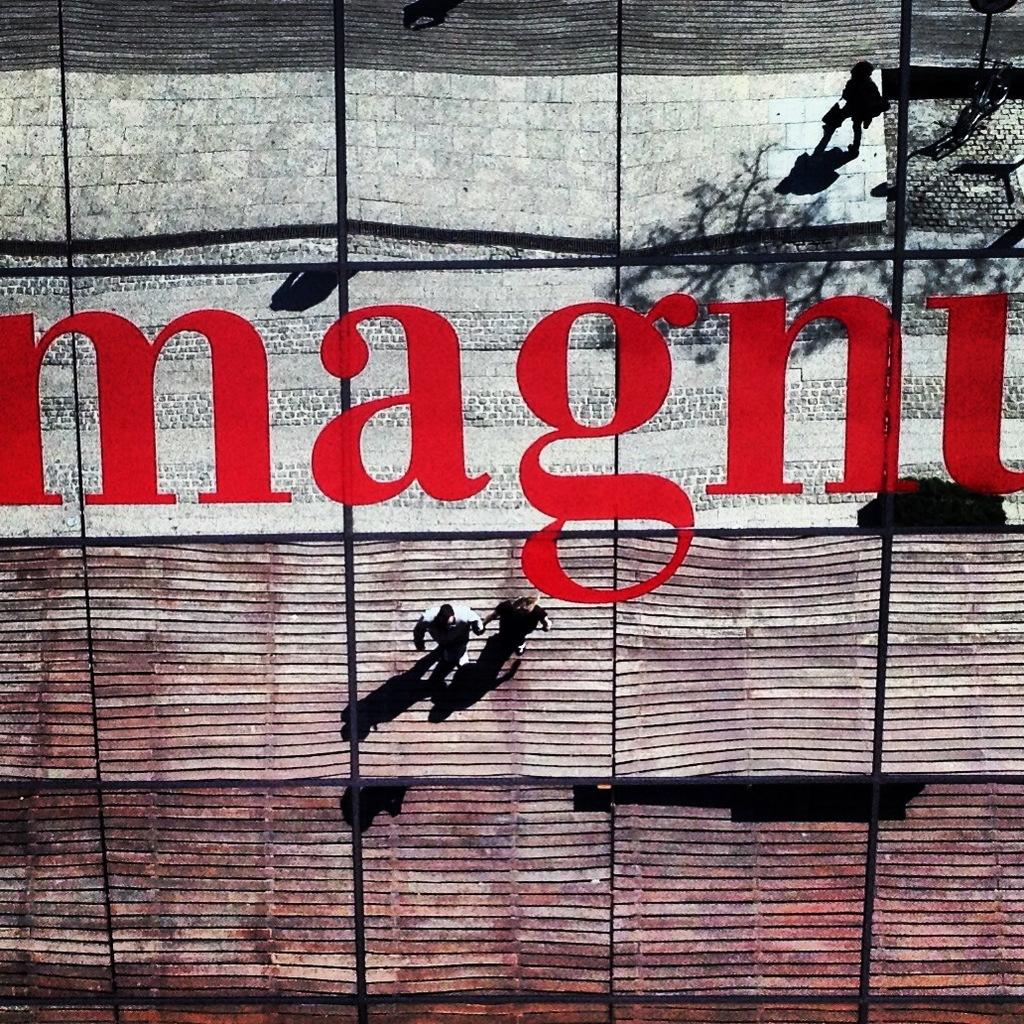Who or what is present in the image? There are people in the image. What are the people doing in the image? The people are walking. What type of celery can be seen in the image? There is no celery present in the image. How many oranges are being carried by the people in the image? There is no mention of oranges in the image, so it cannot be determined if any are being carried. 